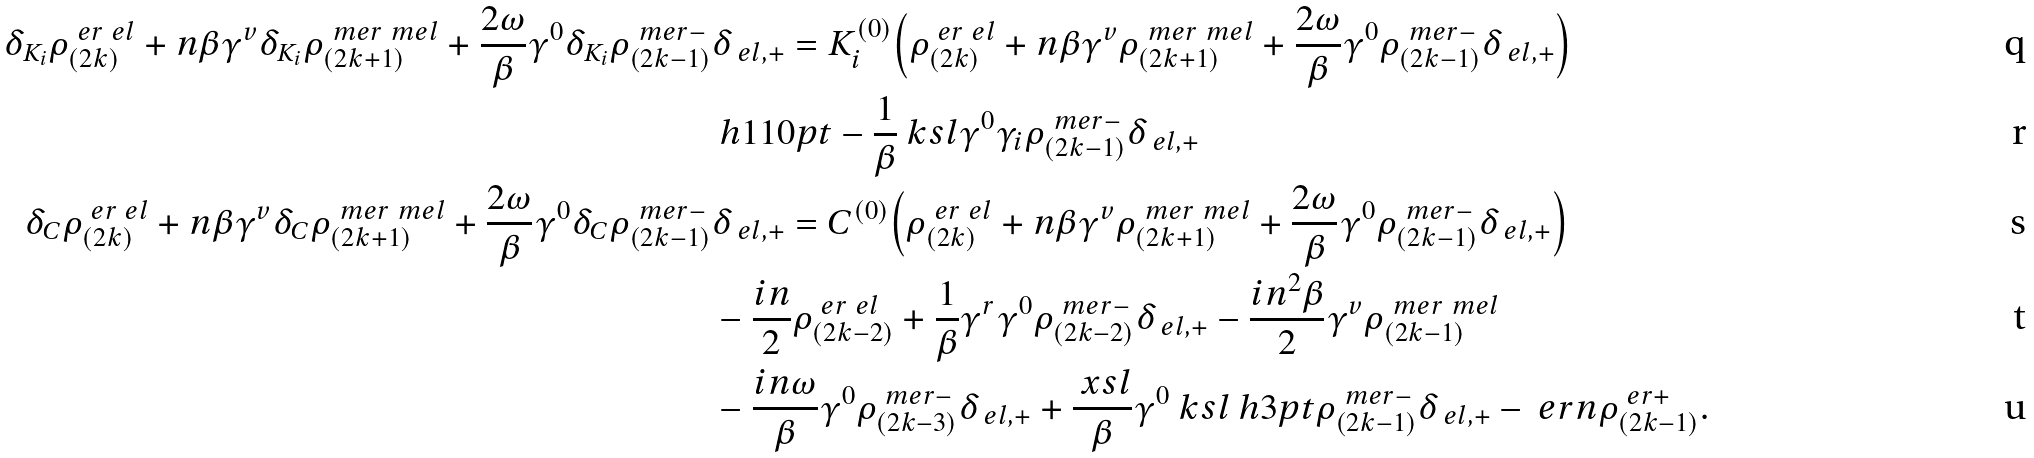<formula> <loc_0><loc_0><loc_500><loc_500>\delta _ { K _ { i } } \rho ^ { \ e r \ e l } _ { ( 2 k ) } + n \beta \gamma ^ { v } \delta _ { K _ { i } } \rho ^ { \ m e r \ m e l } _ { ( 2 k + 1 ) } + \frac { 2 \omega } { \beta } \gamma ^ { 0 } \delta _ { K _ { i } } \rho ^ { \ m e r - } _ { ( 2 k - 1 ) } & \delta _ { \ e l , + } = K _ { i } ^ { ( 0 ) } \Big { ( } \rho ^ { \ e r \ e l } _ { ( 2 k ) } + n \beta \gamma ^ { v } \rho ^ { \ m e r \ m e l } _ { ( 2 k + 1 ) } + \frac { 2 \omega } { \beta } \gamma ^ { 0 } \rho ^ { \ m e r - } _ { ( 2 k - 1 ) } \delta _ { \ e l , + } \Big { ) } \\ & \ h { 1 1 0 p t } - \frac { 1 } { \beta } \ k s l \gamma ^ { 0 } \gamma _ { i } \rho ^ { \ m e r - } _ { ( 2 k - 1 ) } \delta _ { \ e l , + } \\ \delta _ { C } \rho ^ { \ e r \ e l } _ { ( 2 k ) } + n \beta \gamma ^ { v } \delta _ { C } \rho ^ { \ m e r \ m e l } _ { ( 2 k + 1 ) } + \frac { 2 \omega } { \beta } \gamma ^ { 0 } \delta _ { C } \rho ^ { \ m e r - } _ { ( 2 k - 1 ) } & \delta _ { \ e l , + } = C ^ { ( 0 ) } \Big { ( } \rho ^ { \ e r \ e l } _ { ( 2 k ) } + n \beta \gamma ^ { v } \rho ^ { \ m e r \ m e l } _ { ( 2 k + 1 ) } + \frac { 2 \omega } { \beta } \gamma ^ { 0 } \rho ^ { \ m e r - } _ { ( 2 k - 1 ) } \delta _ { \ e l , + } \Big { ) } \\ & - \frac { i n } { 2 } \rho ^ { \ e r \ e l } _ { ( 2 k - 2 ) } + \frac { 1 } { \beta } \gamma ^ { r } \gamma ^ { 0 } \rho ^ { \ m e r - } _ { ( 2 k - 2 ) } \delta _ { \ e l , + } - \frac { i n ^ { 2 } \beta } { 2 } \gamma ^ { v } \rho ^ { \ m e r \ m e l } _ { ( 2 k - 1 ) } \\ & - \frac { i n \omega } { \beta } \gamma ^ { 0 } \rho ^ { \ m e r - } _ { ( 2 k - 3 ) } \delta _ { \ e l , + } + \frac { \ x s l } { \beta } \gamma ^ { 0 } \ k s l \ h { 3 p t } \rho ^ { \ m e r - } _ { ( 2 k - 1 ) } \delta _ { \ e l , + } - \ e r n \rho ^ { \ e r + } _ { ( 2 k - 1 ) } .</formula> 